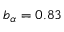<formula> <loc_0><loc_0><loc_500><loc_500>b _ { \alpha } = 0 . 8 3</formula> 